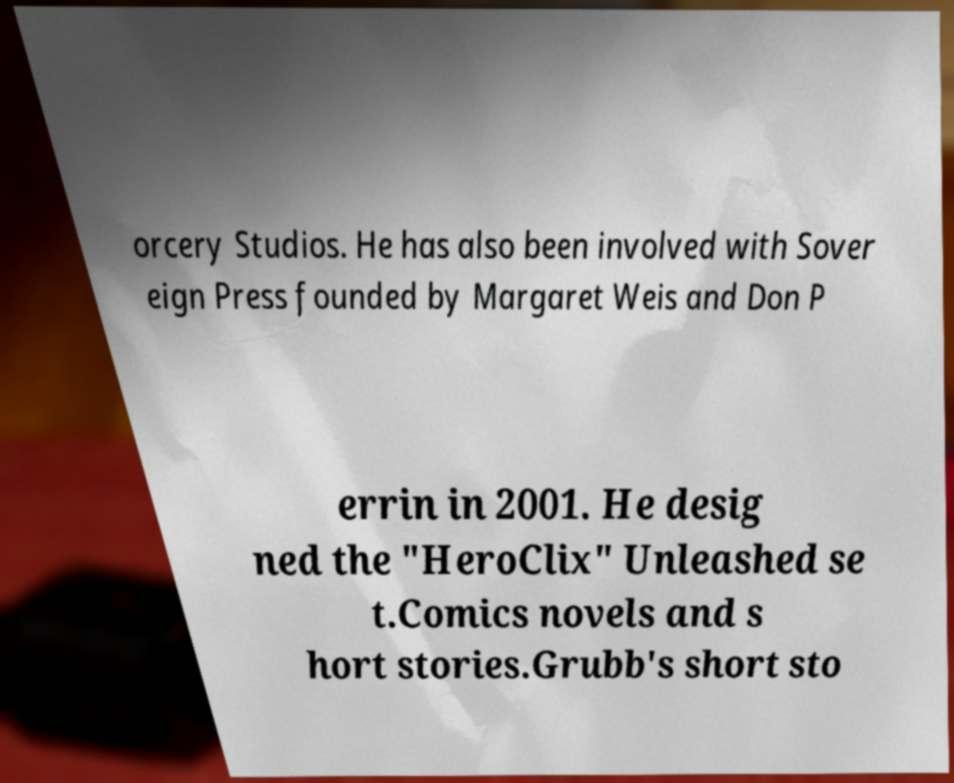Please read and relay the text visible in this image. What does it say? orcery Studios. He has also been involved with Sover eign Press founded by Margaret Weis and Don P errin in 2001. He desig ned the "HeroClix" Unleashed se t.Comics novels and s hort stories.Grubb's short sto 